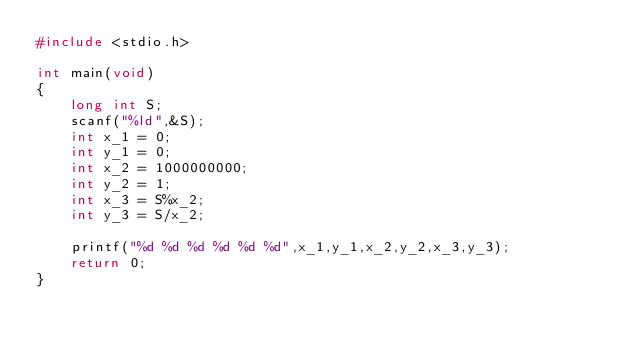<code> <loc_0><loc_0><loc_500><loc_500><_C_>#include <stdio.h>

int main(void)
{
	long int S;
	scanf("%ld",&S);
	int x_1 = 0;
	int y_1 = 0;
	int x_2 = 1000000000;
	int y_2 = 1;
	int x_3 = S%x_2;
	int y_3 = S/x_2;
	
	printf("%d %d %d %d %d %d",x_1,y_1,x_2,y_2,x_3,y_3);
	return 0;
}
</code> 